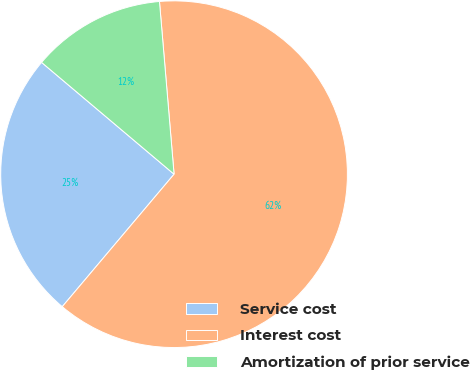Convert chart. <chart><loc_0><loc_0><loc_500><loc_500><pie_chart><fcel>Service cost<fcel>Interest cost<fcel>Amortization of prior service<nl><fcel>25.0%<fcel>62.5%<fcel>12.5%<nl></chart> 